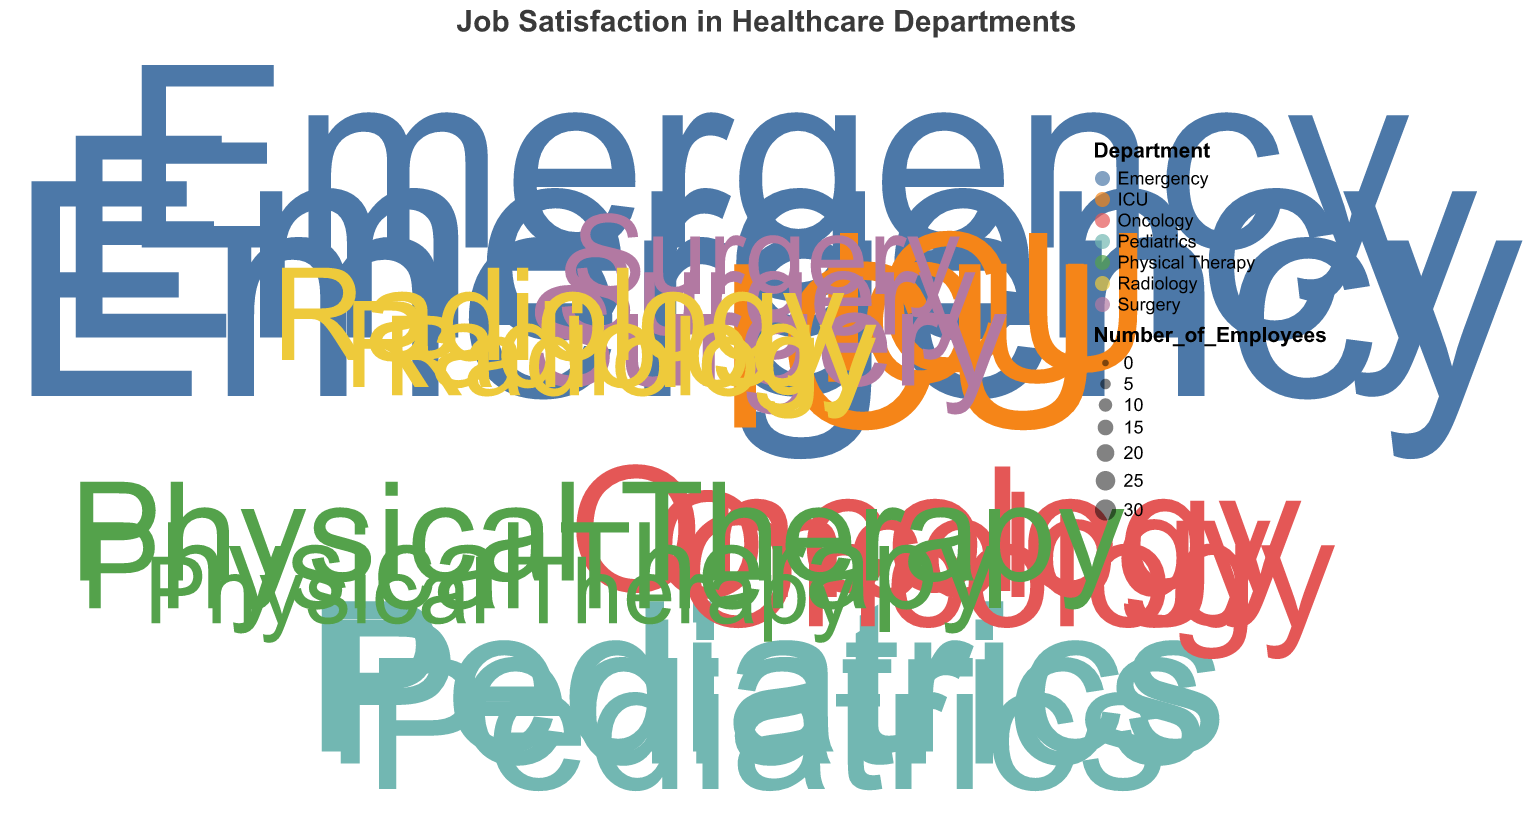What is the title of the chart? Look at the top of the chart to find the text that describes the overall topic.
Answer: Job Satisfaction in Healthcare Departments How many data points represent the ICU department? Count the number of points on the chart labeled with ICU.
Answer: 3 Which department has the highest job satisfaction level? Find the data point with the largest radius value, which shows job satisfaction, and identify its department.
Answer: Physical Therapy Which department has the lowest job satisfaction value? Locate the data point with the smallest radius value and note which department it represents.
Answer: Surgery Which department has the largest number of employees associated with a single data point? Identify the data point with the largest size and check its associated department.
Answer: Emergency What is the average job satisfaction level in the Pediatrics department? Add the job satisfaction levels for all Pediatrics data points and divide by the number of points. (7.9 + 8.1 + 8.5) / 3 = 8.17
Answer: 8.17 Compare the job satisfaction levels between Oncology and Radiology departments. Which one has a higher average? Calculate the average job satisfaction for each department by summing their job satisfaction levels and dividing by the number of data points. Oncology: (8.3 + 7.2 + 7.6) / 3 = 7.7, Radiology: (7.8 + 6.7 + 7.0) / 3 = 7.17. Compare the results.
Answer: Oncology Which department has the most varied job satisfaction levels? Observe the range of job satisfaction levels within each department and identify which has the widest spread between the highest and lowest values.
Answer: Surgery What is the job satisfaction level of the data point with the fewest employees in the chart? Find the smallest data point on the chart and check its radius value for job satisfaction.
Answer: 8.7 How does job satisfaction in the Physical Therapy department compare to Pediatrics? Look at the range and average of job satisfaction levels in both departments and analyze the differences. Physical Therapy (7.2 to 8.7), Pediatrics (7.9 to 8.5). Physical Therapy has both higher variability and potentially higher satisfaction.
Answer: Physical Therapy has higher variability 